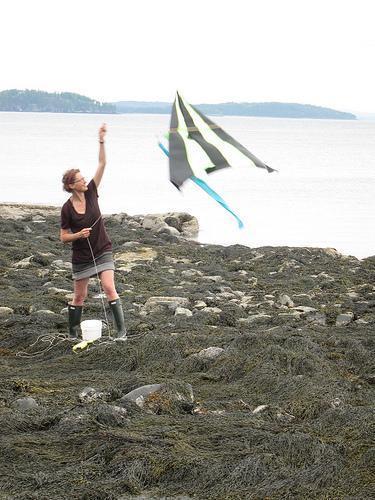How many people are shown?
Give a very brief answer. 1. 